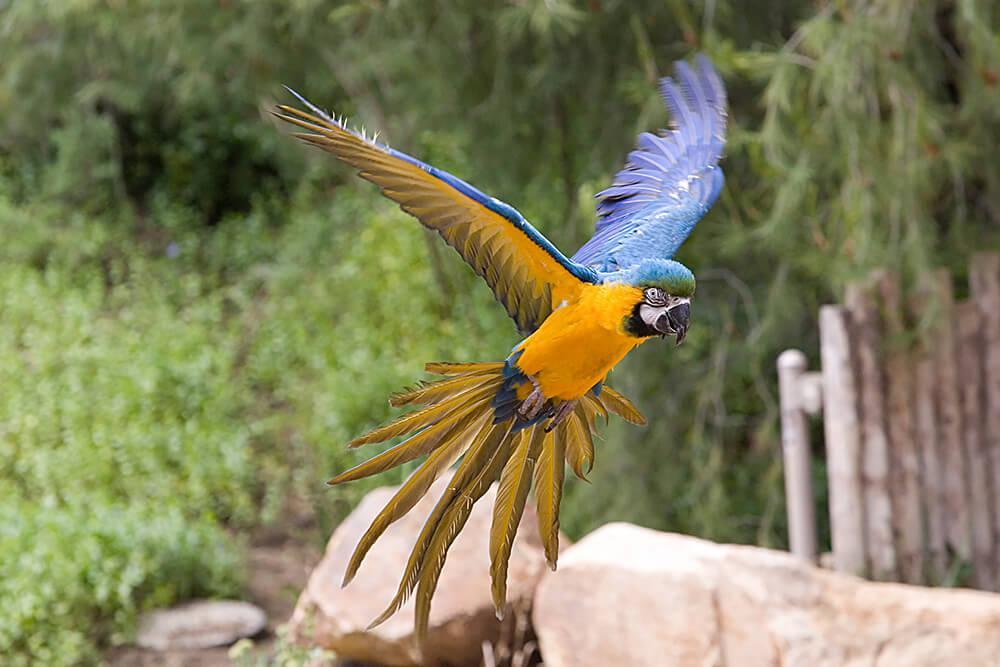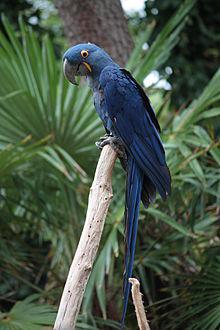The first image is the image on the left, the second image is the image on the right. For the images displayed, is the sentence "There are several parrots, definitely more than two." factually correct? Answer yes or no. No. The first image is the image on the left, the second image is the image on the right. Given the left and right images, does the statement "There are at most two birds." hold true? Answer yes or no. Yes. 